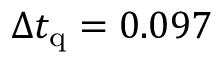Convert formula to latex. <formula><loc_0><loc_0><loc_500><loc_500>\Delta t _ { q } = 0 . 0 9 7</formula> 